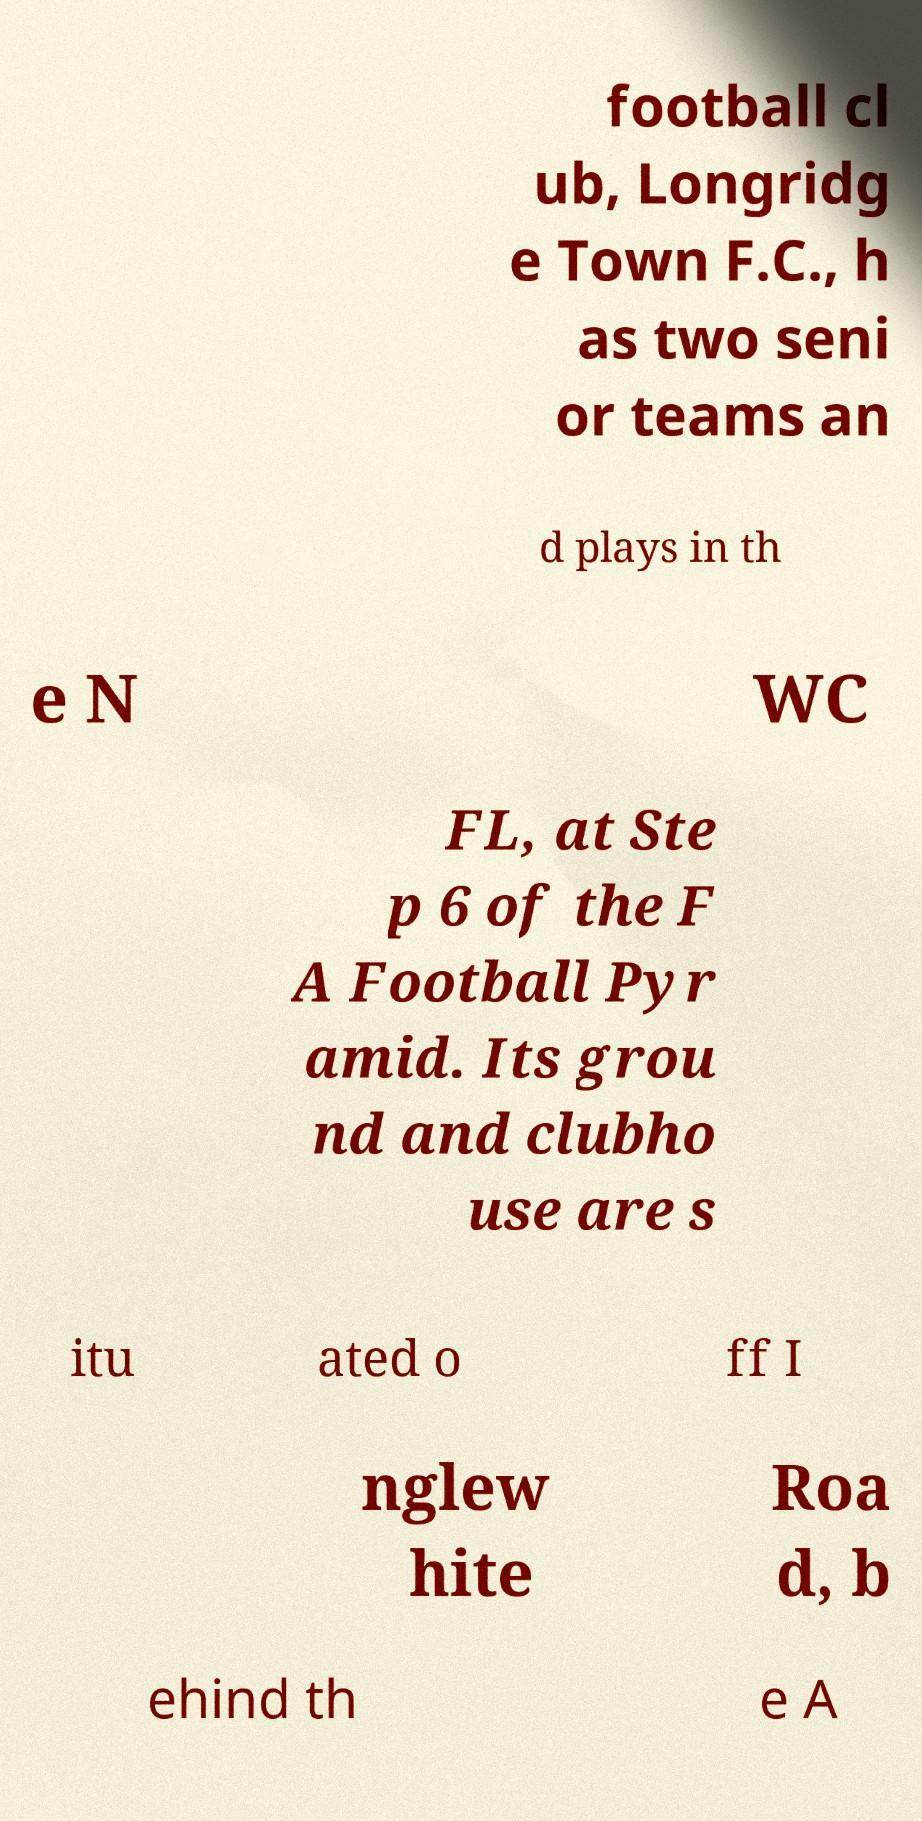Could you assist in decoding the text presented in this image and type it out clearly? football cl ub, Longridg e Town F.C., h as two seni or teams an d plays in th e N WC FL, at Ste p 6 of the F A Football Pyr amid. Its grou nd and clubho use are s itu ated o ff I nglew hite Roa d, b ehind th e A 